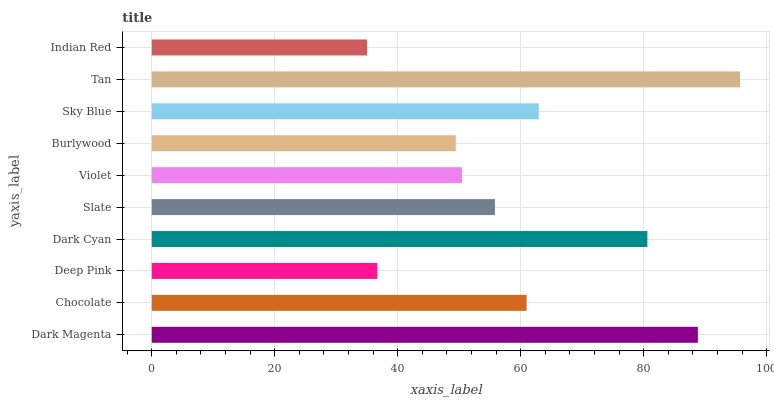Is Indian Red the minimum?
Answer yes or no. Yes. Is Tan the maximum?
Answer yes or no. Yes. Is Chocolate the minimum?
Answer yes or no. No. Is Chocolate the maximum?
Answer yes or no. No. Is Dark Magenta greater than Chocolate?
Answer yes or no. Yes. Is Chocolate less than Dark Magenta?
Answer yes or no. Yes. Is Chocolate greater than Dark Magenta?
Answer yes or no. No. Is Dark Magenta less than Chocolate?
Answer yes or no. No. Is Chocolate the high median?
Answer yes or no. Yes. Is Slate the low median?
Answer yes or no. Yes. Is Burlywood the high median?
Answer yes or no. No. Is Dark Cyan the low median?
Answer yes or no. No. 